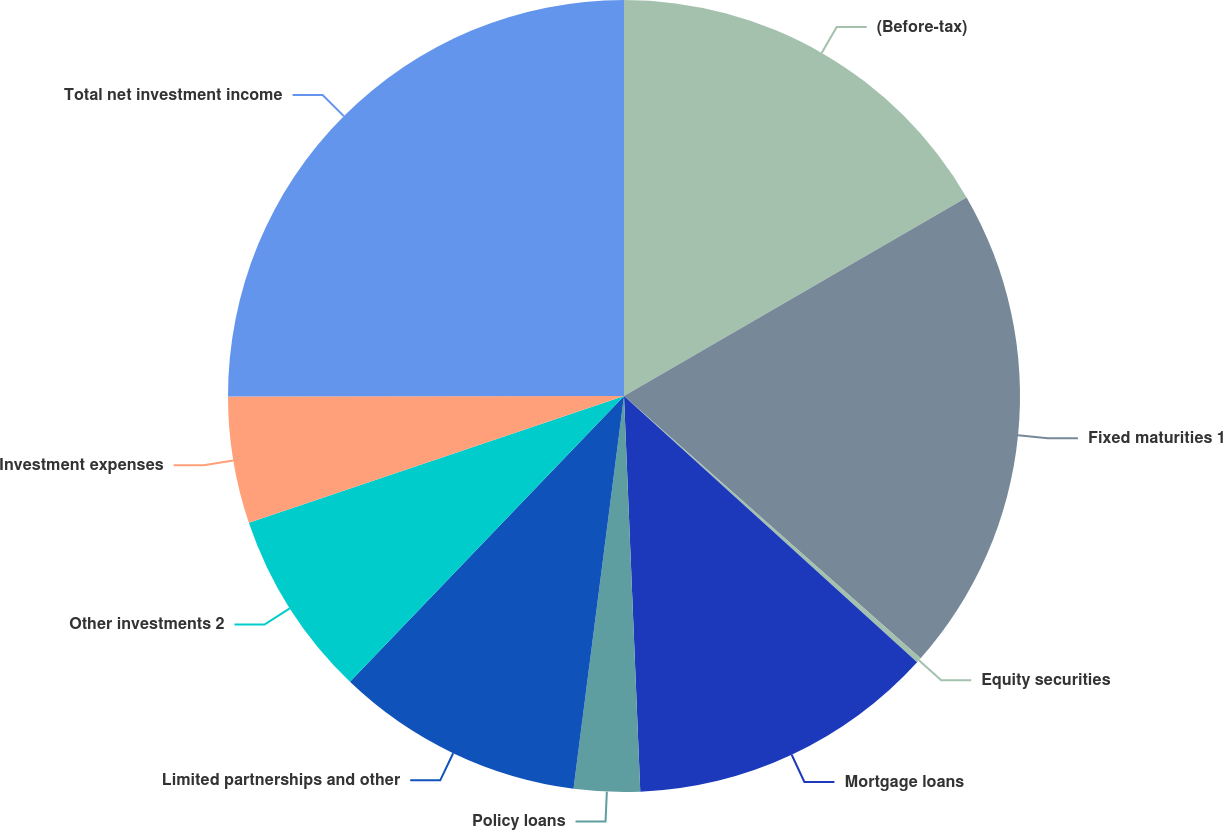Convert chart to OTSL. <chart><loc_0><loc_0><loc_500><loc_500><pie_chart><fcel>(Before-tax)<fcel>Fixed maturities 1<fcel>Equity securities<fcel>Mortgage loans<fcel>Policy loans<fcel>Limited partnerships and other<fcel>Other investments 2<fcel>Investment expenses<fcel>Total net investment income<nl><fcel>16.64%<fcel>19.89%<fcel>0.21%<fcel>12.61%<fcel>2.69%<fcel>10.13%<fcel>7.65%<fcel>5.17%<fcel>25.02%<nl></chart> 